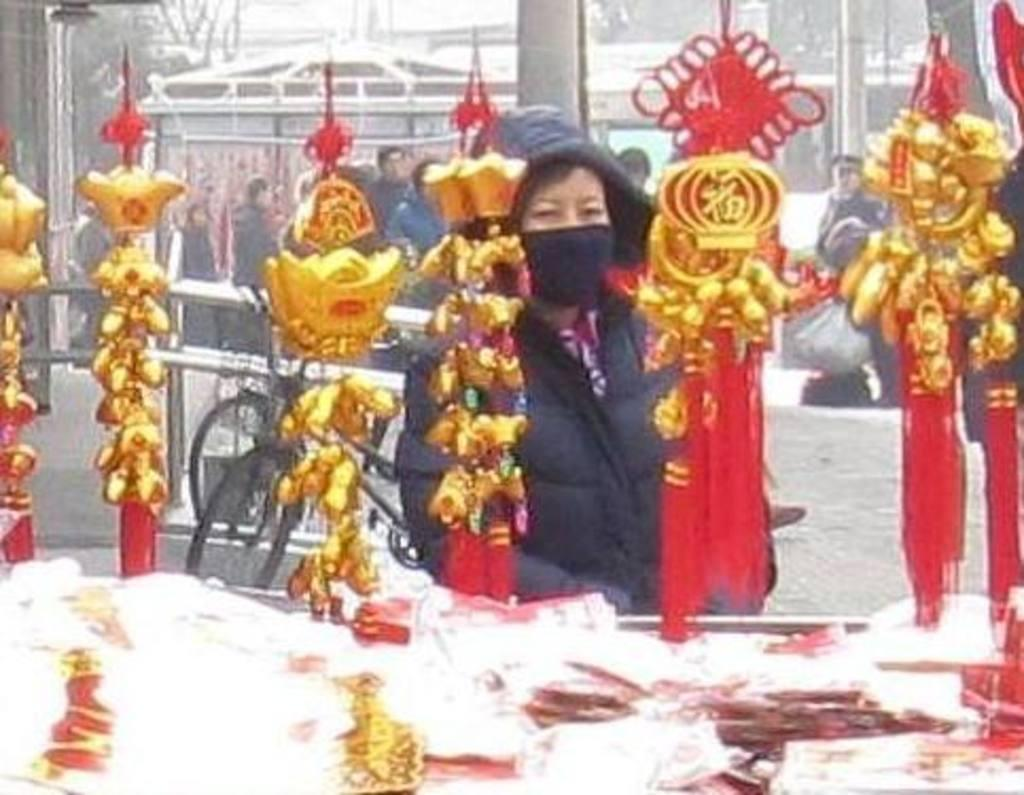What is hanging in the image? There are hangings in the image. What is located behind the hangings? There is a bicycle behind the hangings. What is at the bottom of the image? There is a table at the bottom of the image. What can be found on the table? There are products on the table. What type of food is being offered on the table in the image? There is no food present on the table in the image; it contains products. What place is depicted in the image? The image does not depict a specific place; it only shows hangings, a bicycle, a table, and products. 